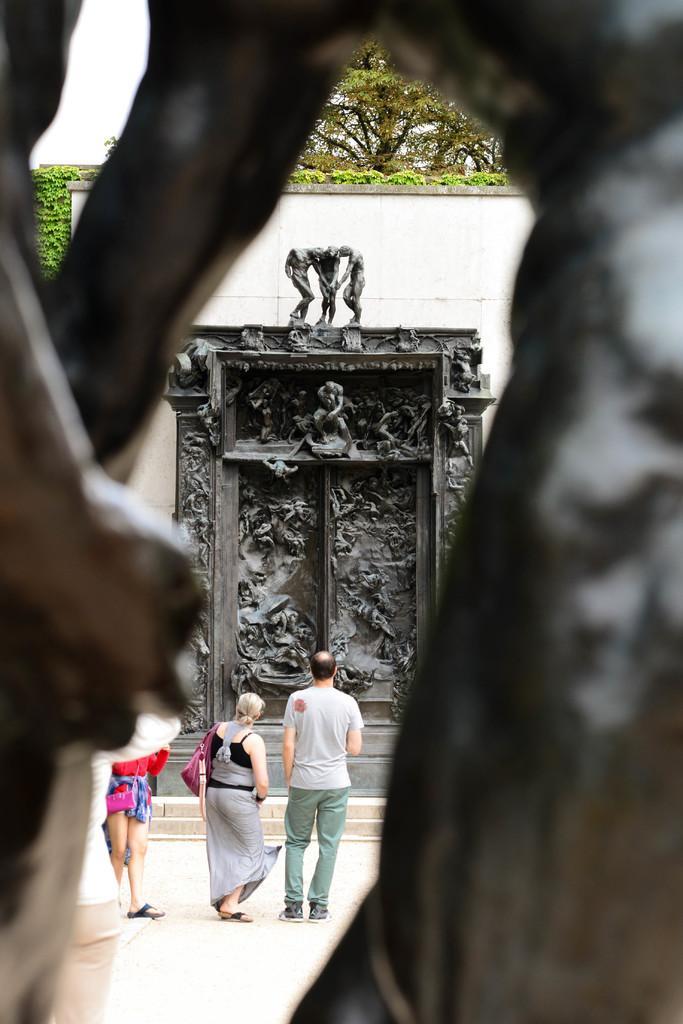Please provide a concise description of this image. This picture seems to be clicked outside. In the foreground we can see the sculptures of some objects. In the center we can see the group of persons seems to be standing on the ground. In the background we can see the wall, trees and green leaves and we can see the sculptures of group of persons and sculptures of many other objects. 